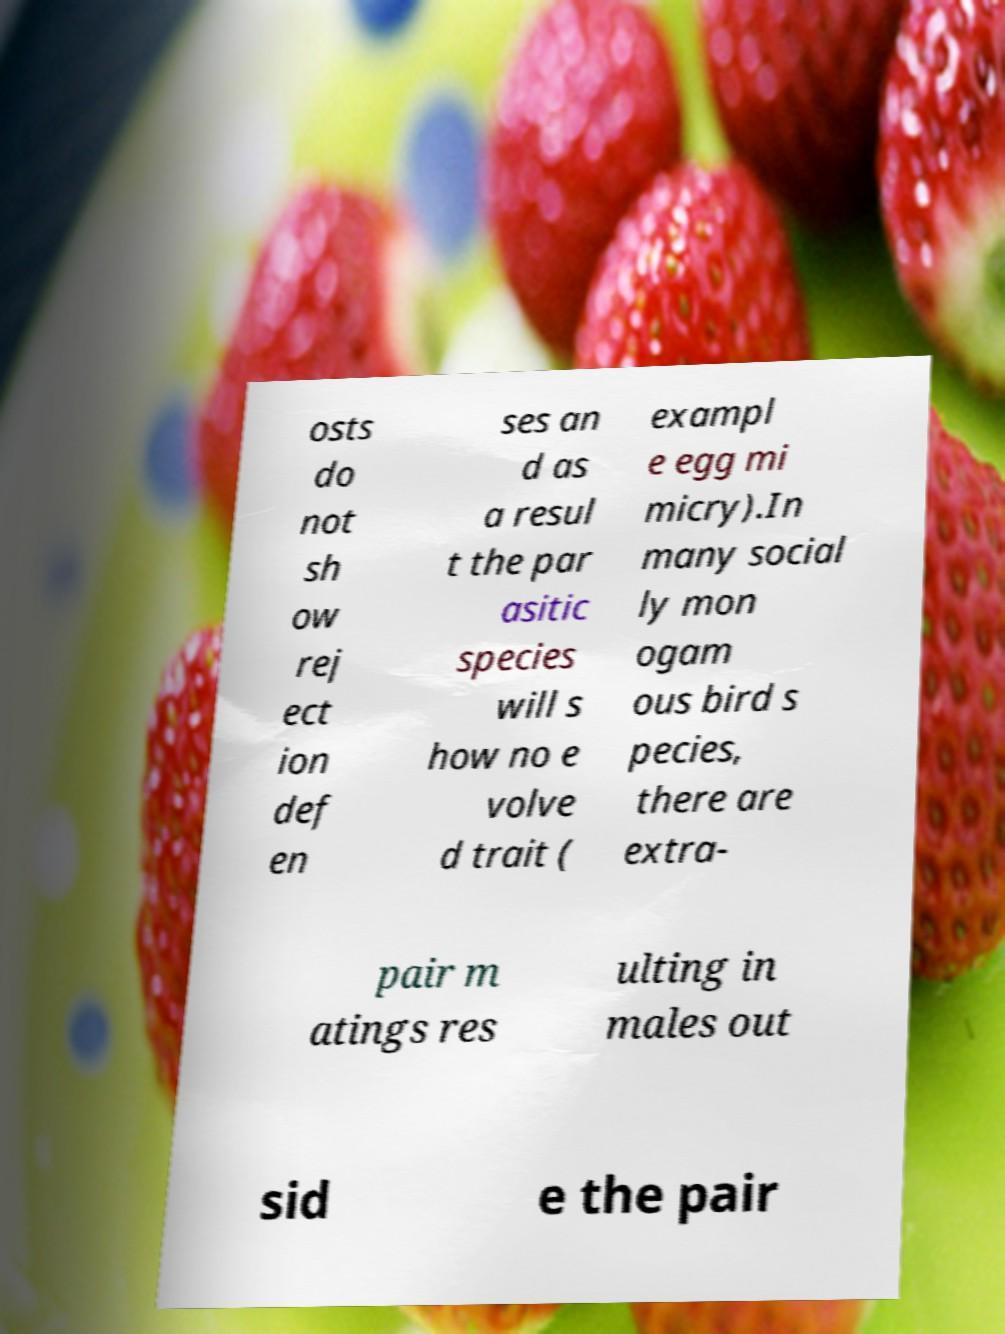For documentation purposes, I need the text within this image transcribed. Could you provide that? osts do not sh ow rej ect ion def en ses an d as a resul t the par asitic species will s how no e volve d trait ( exampl e egg mi micry).In many social ly mon ogam ous bird s pecies, there are extra- pair m atings res ulting in males out sid e the pair 